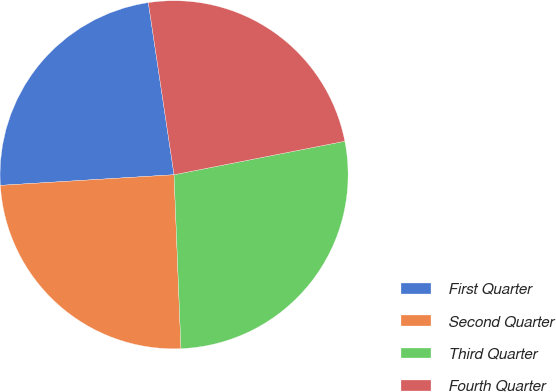<chart> <loc_0><loc_0><loc_500><loc_500><pie_chart><fcel>First Quarter<fcel>Second Quarter<fcel>Third Quarter<fcel>Fourth Quarter<nl><fcel>23.61%<fcel>24.66%<fcel>27.45%<fcel>24.28%<nl></chart> 